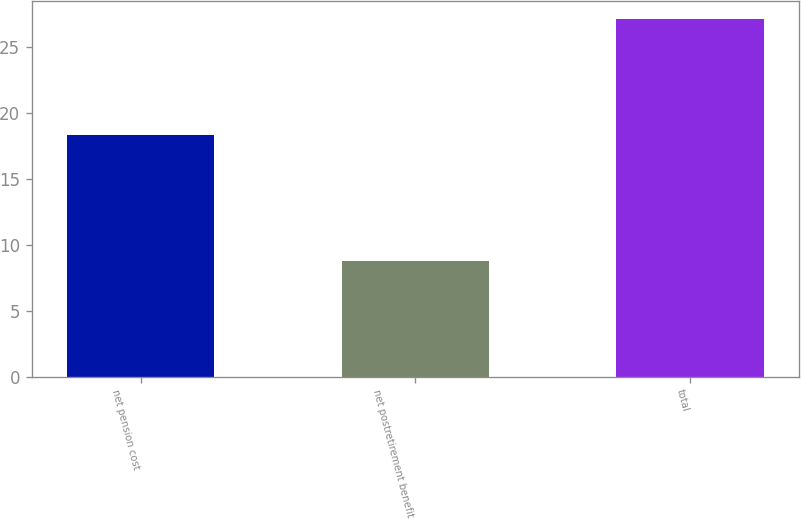Convert chart. <chart><loc_0><loc_0><loc_500><loc_500><bar_chart><fcel>net pension cost<fcel>net postretirement benefit<fcel>total<nl><fcel>18.3<fcel>8.8<fcel>27.1<nl></chart> 